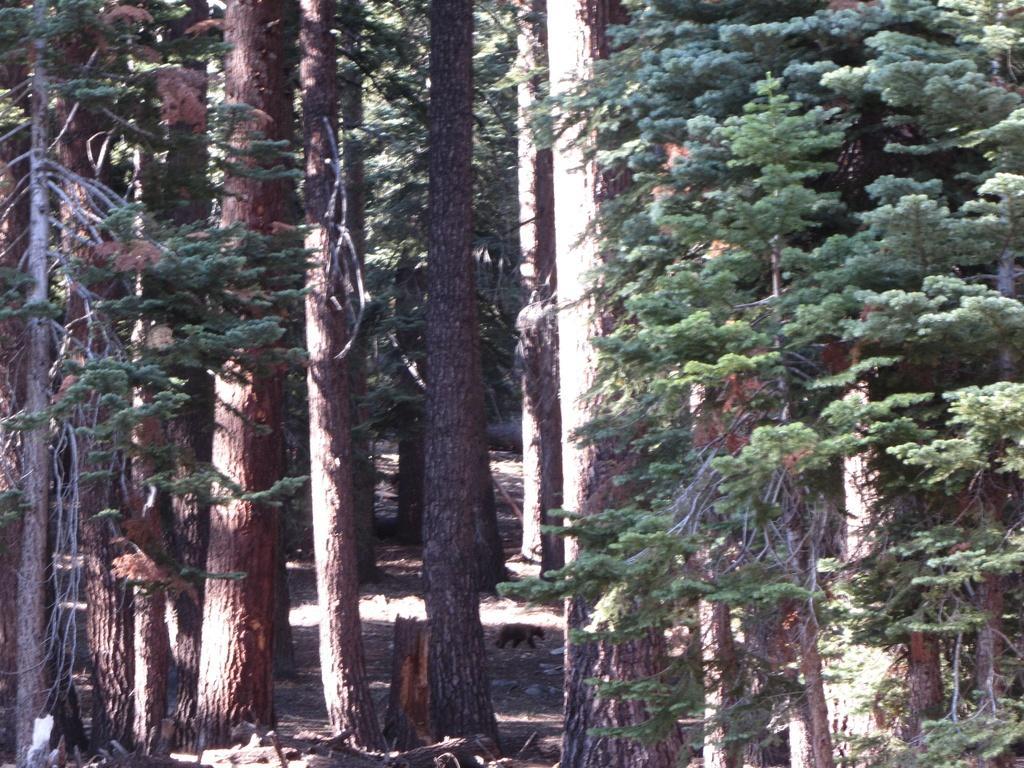Could you give a brief overview of what you see in this image? In this image there are some trees as we can see in middle of this image and there is one bear at bottom of this image. 